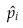<formula> <loc_0><loc_0><loc_500><loc_500>\hat { p } _ { i }</formula> 